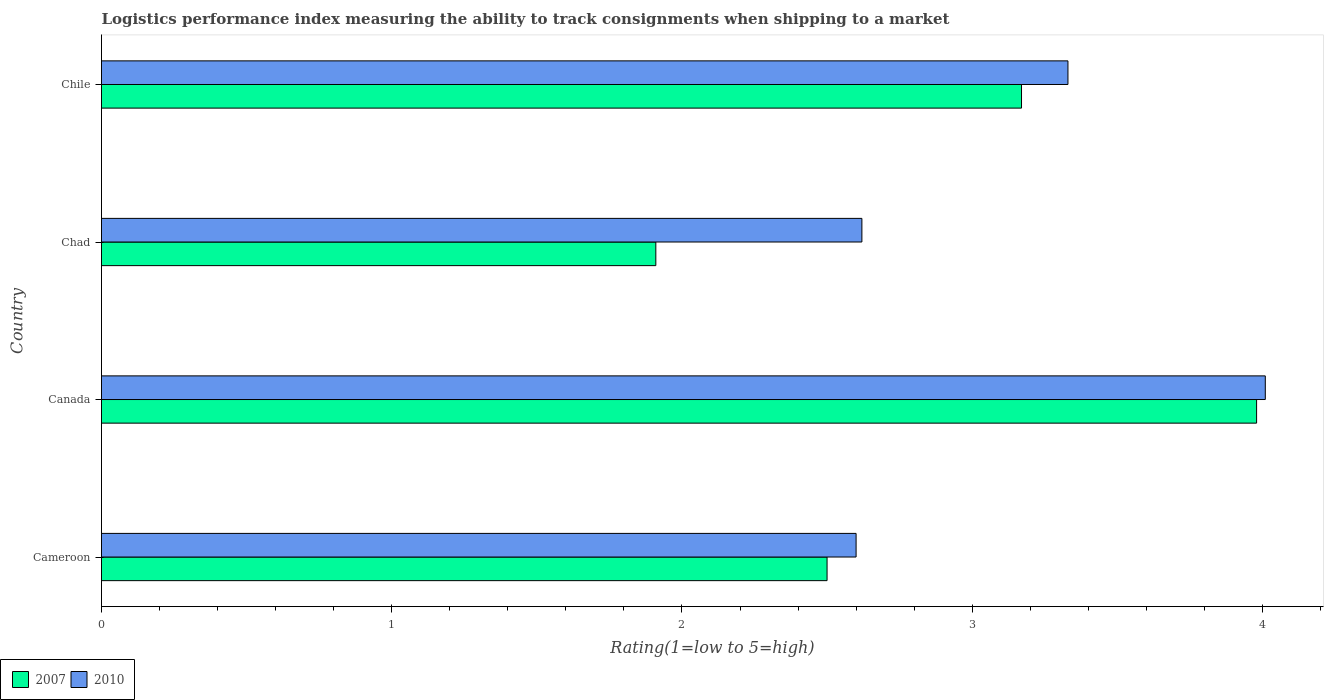How many different coloured bars are there?
Keep it short and to the point. 2. How many groups of bars are there?
Your answer should be compact. 4. Are the number of bars on each tick of the Y-axis equal?
Your answer should be compact. Yes. How many bars are there on the 3rd tick from the top?
Your answer should be very brief. 2. How many bars are there on the 2nd tick from the bottom?
Offer a terse response. 2. What is the label of the 2nd group of bars from the top?
Ensure brevity in your answer.  Chad. What is the Logistic performance index in 2010 in Canada?
Offer a terse response. 4.01. Across all countries, what is the maximum Logistic performance index in 2007?
Provide a succinct answer. 3.98. Across all countries, what is the minimum Logistic performance index in 2010?
Your answer should be very brief. 2.6. In which country was the Logistic performance index in 2010 maximum?
Ensure brevity in your answer.  Canada. In which country was the Logistic performance index in 2010 minimum?
Provide a short and direct response. Cameroon. What is the total Logistic performance index in 2007 in the graph?
Give a very brief answer. 11.56. What is the difference between the Logistic performance index in 2007 in Chad and that in Chile?
Make the answer very short. -1.26. What is the difference between the Logistic performance index in 2007 in Chile and the Logistic performance index in 2010 in Cameroon?
Your response must be concise. 0.57. What is the average Logistic performance index in 2007 per country?
Your answer should be very brief. 2.89. What is the difference between the Logistic performance index in 2007 and Logistic performance index in 2010 in Chile?
Offer a terse response. -0.16. In how many countries, is the Logistic performance index in 2007 greater than 0.8 ?
Keep it short and to the point. 4. What is the ratio of the Logistic performance index in 2007 in Canada to that in Chile?
Provide a succinct answer. 1.26. What is the difference between the highest and the second highest Logistic performance index in 2007?
Offer a very short reply. 0.81. What is the difference between the highest and the lowest Logistic performance index in 2010?
Keep it short and to the point. 1.41. What does the 1st bar from the top in Cameroon represents?
Offer a terse response. 2010. Are all the bars in the graph horizontal?
Provide a succinct answer. Yes. Are the values on the major ticks of X-axis written in scientific E-notation?
Your answer should be compact. No. Does the graph contain any zero values?
Your answer should be compact. No. Where does the legend appear in the graph?
Your answer should be compact. Bottom left. How many legend labels are there?
Your response must be concise. 2. What is the title of the graph?
Provide a short and direct response. Logistics performance index measuring the ability to track consignments when shipping to a market. What is the label or title of the X-axis?
Provide a succinct answer. Rating(1=low to 5=high). What is the Rating(1=low to 5=high) in 2007 in Cameroon?
Offer a very short reply. 2.5. What is the Rating(1=low to 5=high) in 2007 in Canada?
Your response must be concise. 3.98. What is the Rating(1=low to 5=high) of 2010 in Canada?
Give a very brief answer. 4.01. What is the Rating(1=low to 5=high) in 2007 in Chad?
Your response must be concise. 1.91. What is the Rating(1=low to 5=high) of 2010 in Chad?
Provide a short and direct response. 2.62. What is the Rating(1=low to 5=high) of 2007 in Chile?
Ensure brevity in your answer.  3.17. What is the Rating(1=low to 5=high) of 2010 in Chile?
Offer a very short reply. 3.33. Across all countries, what is the maximum Rating(1=low to 5=high) of 2007?
Make the answer very short. 3.98. Across all countries, what is the maximum Rating(1=low to 5=high) of 2010?
Your answer should be very brief. 4.01. Across all countries, what is the minimum Rating(1=low to 5=high) in 2007?
Ensure brevity in your answer.  1.91. What is the total Rating(1=low to 5=high) in 2007 in the graph?
Make the answer very short. 11.56. What is the total Rating(1=low to 5=high) of 2010 in the graph?
Your answer should be compact. 12.56. What is the difference between the Rating(1=low to 5=high) in 2007 in Cameroon and that in Canada?
Provide a short and direct response. -1.48. What is the difference between the Rating(1=low to 5=high) of 2010 in Cameroon and that in Canada?
Give a very brief answer. -1.41. What is the difference between the Rating(1=low to 5=high) of 2007 in Cameroon and that in Chad?
Your answer should be compact. 0.59. What is the difference between the Rating(1=low to 5=high) of 2010 in Cameroon and that in Chad?
Provide a succinct answer. -0.02. What is the difference between the Rating(1=low to 5=high) of 2007 in Cameroon and that in Chile?
Your answer should be compact. -0.67. What is the difference between the Rating(1=low to 5=high) of 2010 in Cameroon and that in Chile?
Offer a very short reply. -0.73. What is the difference between the Rating(1=low to 5=high) of 2007 in Canada and that in Chad?
Give a very brief answer. 2.07. What is the difference between the Rating(1=low to 5=high) in 2010 in Canada and that in Chad?
Ensure brevity in your answer.  1.39. What is the difference between the Rating(1=low to 5=high) in 2007 in Canada and that in Chile?
Offer a terse response. 0.81. What is the difference between the Rating(1=low to 5=high) in 2010 in Canada and that in Chile?
Offer a terse response. 0.68. What is the difference between the Rating(1=low to 5=high) of 2007 in Chad and that in Chile?
Ensure brevity in your answer.  -1.26. What is the difference between the Rating(1=low to 5=high) of 2010 in Chad and that in Chile?
Your response must be concise. -0.71. What is the difference between the Rating(1=low to 5=high) of 2007 in Cameroon and the Rating(1=low to 5=high) of 2010 in Canada?
Ensure brevity in your answer.  -1.51. What is the difference between the Rating(1=low to 5=high) of 2007 in Cameroon and the Rating(1=low to 5=high) of 2010 in Chad?
Your answer should be very brief. -0.12. What is the difference between the Rating(1=low to 5=high) in 2007 in Cameroon and the Rating(1=low to 5=high) in 2010 in Chile?
Provide a succinct answer. -0.83. What is the difference between the Rating(1=low to 5=high) in 2007 in Canada and the Rating(1=low to 5=high) in 2010 in Chad?
Make the answer very short. 1.36. What is the difference between the Rating(1=low to 5=high) of 2007 in Canada and the Rating(1=low to 5=high) of 2010 in Chile?
Make the answer very short. 0.65. What is the difference between the Rating(1=low to 5=high) in 2007 in Chad and the Rating(1=low to 5=high) in 2010 in Chile?
Your response must be concise. -1.42. What is the average Rating(1=low to 5=high) of 2007 per country?
Offer a very short reply. 2.89. What is the average Rating(1=low to 5=high) in 2010 per country?
Offer a very short reply. 3.14. What is the difference between the Rating(1=low to 5=high) in 2007 and Rating(1=low to 5=high) in 2010 in Cameroon?
Offer a terse response. -0.1. What is the difference between the Rating(1=low to 5=high) of 2007 and Rating(1=low to 5=high) of 2010 in Canada?
Ensure brevity in your answer.  -0.03. What is the difference between the Rating(1=low to 5=high) in 2007 and Rating(1=low to 5=high) in 2010 in Chad?
Your answer should be very brief. -0.71. What is the difference between the Rating(1=low to 5=high) of 2007 and Rating(1=low to 5=high) of 2010 in Chile?
Your answer should be very brief. -0.16. What is the ratio of the Rating(1=low to 5=high) in 2007 in Cameroon to that in Canada?
Your answer should be very brief. 0.63. What is the ratio of the Rating(1=low to 5=high) in 2010 in Cameroon to that in Canada?
Your response must be concise. 0.65. What is the ratio of the Rating(1=low to 5=high) in 2007 in Cameroon to that in Chad?
Offer a terse response. 1.31. What is the ratio of the Rating(1=low to 5=high) in 2010 in Cameroon to that in Chad?
Offer a very short reply. 0.99. What is the ratio of the Rating(1=low to 5=high) in 2007 in Cameroon to that in Chile?
Provide a short and direct response. 0.79. What is the ratio of the Rating(1=low to 5=high) in 2010 in Cameroon to that in Chile?
Your answer should be very brief. 0.78. What is the ratio of the Rating(1=low to 5=high) of 2007 in Canada to that in Chad?
Offer a very short reply. 2.08. What is the ratio of the Rating(1=low to 5=high) in 2010 in Canada to that in Chad?
Provide a succinct answer. 1.53. What is the ratio of the Rating(1=low to 5=high) of 2007 in Canada to that in Chile?
Provide a short and direct response. 1.26. What is the ratio of the Rating(1=low to 5=high) in 2010 in Canada to that in Chile?
Offer a very short reply. 1.2. What is the ratio of the Rating(1=low to 5=high) in 2007 in Chad to that in Chile?
Offer a terse response. 0.6. What is the ratio of the Rating(1=low to 5=high) of 2010 in Chad to that in Chile?
Offer a terse response. 0.79. What is the difference between the highest and the second highest Rating(1=low to 5=high) in 2007?
Make the answer very short. 0.81. What is the difference between the highest and the second highest Rating(1=low to 5=high) of 2010?
Your response must be concise. 0.68. What is the difference between the highest and the lowest Rating(1=low to 5=high) in 2007?
Give a very brief answer. 2.07. What is the difference between the highest and the lowest Rating(1=low to 5=high) in 2010?
Provide a short and direct response. 1.41. 